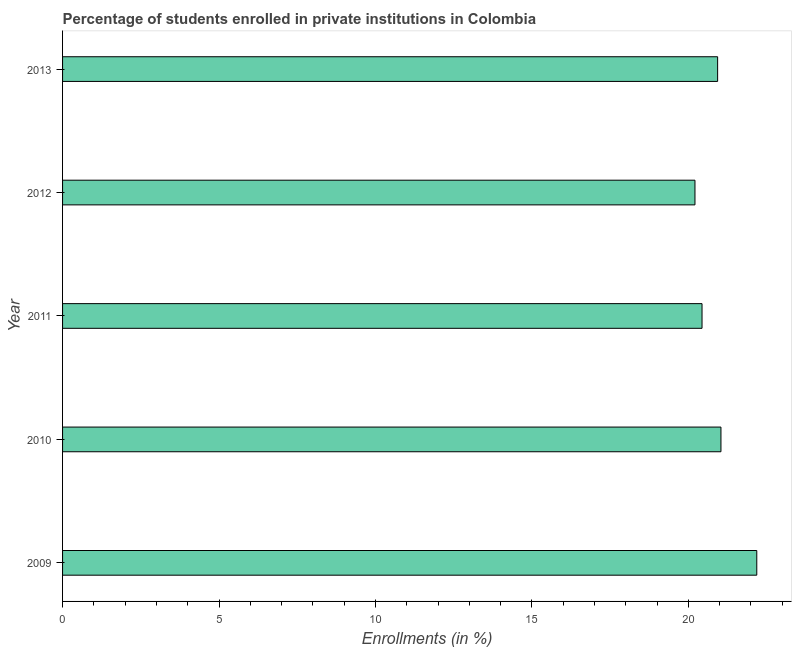What is the title of the graph?
Keep it short and to the point. Percentage of students enrolled in private institutions in Colombia. What is the label or title of the X-axis?
Provide a succinct answer. Enrollments (in %). What is the label or title of the Y-axis?
Keep it short and to the point. Year. What is the enrollments in private institutions in 2012?
Offer a terse response. 20.21. Across all years, what is the maximum enrollments in private institutions?
Provide a short and direct response. 22.19. Across all years, what is the minimum enrollments in private institutions?
Your answer should be very brief. 20.21. In which year was the enrollments in private institutions maximum?
Offer a very short reply. 2009. What is the sum of the enrollments in private institutions?
Keep it short and to the point. 104.82. What is the average enrollments in private institutions per year?
Offer a terse response. 20.96. What is the median enrollments in private institutions?
Offer a terse response. 20.94. In how many years, is the enrollments in private institutions greater than 8 %?
Offer a terse response. 5. What is the ratio of the enrollments in private institutions in 2009 to that in 2012?
Ensure brevity in your answer.  1.1. What is the difference between the highest and the second highest enrollments in private institutions?
Offer a very short reply. 1.15. What is the difference between the highest and the lowest enrollments in private institutions?
Ensure brevity in your answer.  1.98. How many bars are there?
Make the answer very short. 5. Are all the bars in the graph horizontal?
Keep it short and to the point. Yes. How many years are there in the graph?
Offer a terse response. 5. What is the Enrollments (in %) in 2009?
Your answer should be compact. 22.19. What is the Enrollments (in %) in 2010?
Make the answer very short. 21.04. What is the Enrollments (in %) of 2011?
Your answer should be compact. 20.44. What is the Enrollments (in %) in 2012?
Your answer should be very brief. 20.21. What is the Enrollments (in %) in 2013?
Keep it short and to the point. 20.94. What is the difference between the Enrollments (in %) in 2009 and 2010?
Make the answer very short. 1.15. What is the difference between the Enrollments (in %) in 2009 and 2011?
Provide a succinct answer. 1.75. What is the difference between the Enrollments (in %) in 2009 and 2012?
Make the answer very short. 1.98. What is the difference between the Enrollments (in %) in 2009 and 2013?
Ensure brevity in your answer.  1.25. What is the difference between the Enrollments (in %) in 2010 and 2011?
Your answer should be compact. 0.6. What is the difference between the Enrollments (in %) in 2010 and 2012?
Keep it short and to the point. 0.83. What is the difference between the Enrollments (in %) in 2010 and 2013?
Make the answer very short. 0.11. What is the difference between the Enrollments (in %) in 2011 and 2012?
Keep it short and to the point. 0.23. What is the difference between the Enrollments (in %) in 2011 and 2013?
Your answer should be very brief. -0.5. What is the difference between the Enrollments (in %) in 2012 and 2013?
Keep it short and to the point. -0.72. What is the ratio of the Enrollments (in %) in 2009 to that in 2010?
Ensure brevity in your answer.  1.05. What is the ratio of the Enrollments (in %) in 2009 to that in 2011?
Make the answer very short. 1.09. What is the ratio of the Enrollments (in %) in 2009 to that in 2012?
Provide a short and direct response. 1.1. What is the ratio of the Enrollments (in %) in 2009 to that in 2013?
Provide a short and direct response. 1.06. What is the ratio of the Enrollments (in %) in 2010 to that in 2012?
Make the answer very short. 1.04. What is the ratio of the Enrollments (in %) in 2010 to that in 2013?
Ensure brevity in your answer.  1. 